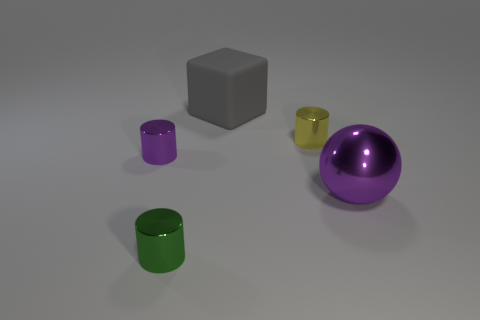What number of other things are there of the same color as the big matte object?
Provide a short and direct response. 0. Is the number of green cylinders left of the large matte cube greater than the number of gray objects that are left of the green metallic object?
Your answer should be very brief. Yes. Is there anything else that has the same size as the green object?
Offer a very short reply. Yes. What number of cylinders are gray objects or small things?
Offer a very short reply. 3. How many objects are either large metal things in front of the purple shiny cylinder or small things?
Your answer should be very brief. 4. The thing that is to the right of the metallic cylinder that is right of the metal object that is in front of the large purple thing is what shape?
Your answer should be very brief. Sphere. What number of small cyan matte things are the same shape as the green shiny object?
Make the answer very short. 0. Are the yellow thing and the large purple thing made of the same material?
Keep it short and to the point. Yes. What number of small green things are in front of the small thing on the left side of the cylinder in front of the ball?
Provide a short and direct response. 1. Is there a green ball that has the same material as the yellow cylinder?
Make the answer very short. No. 